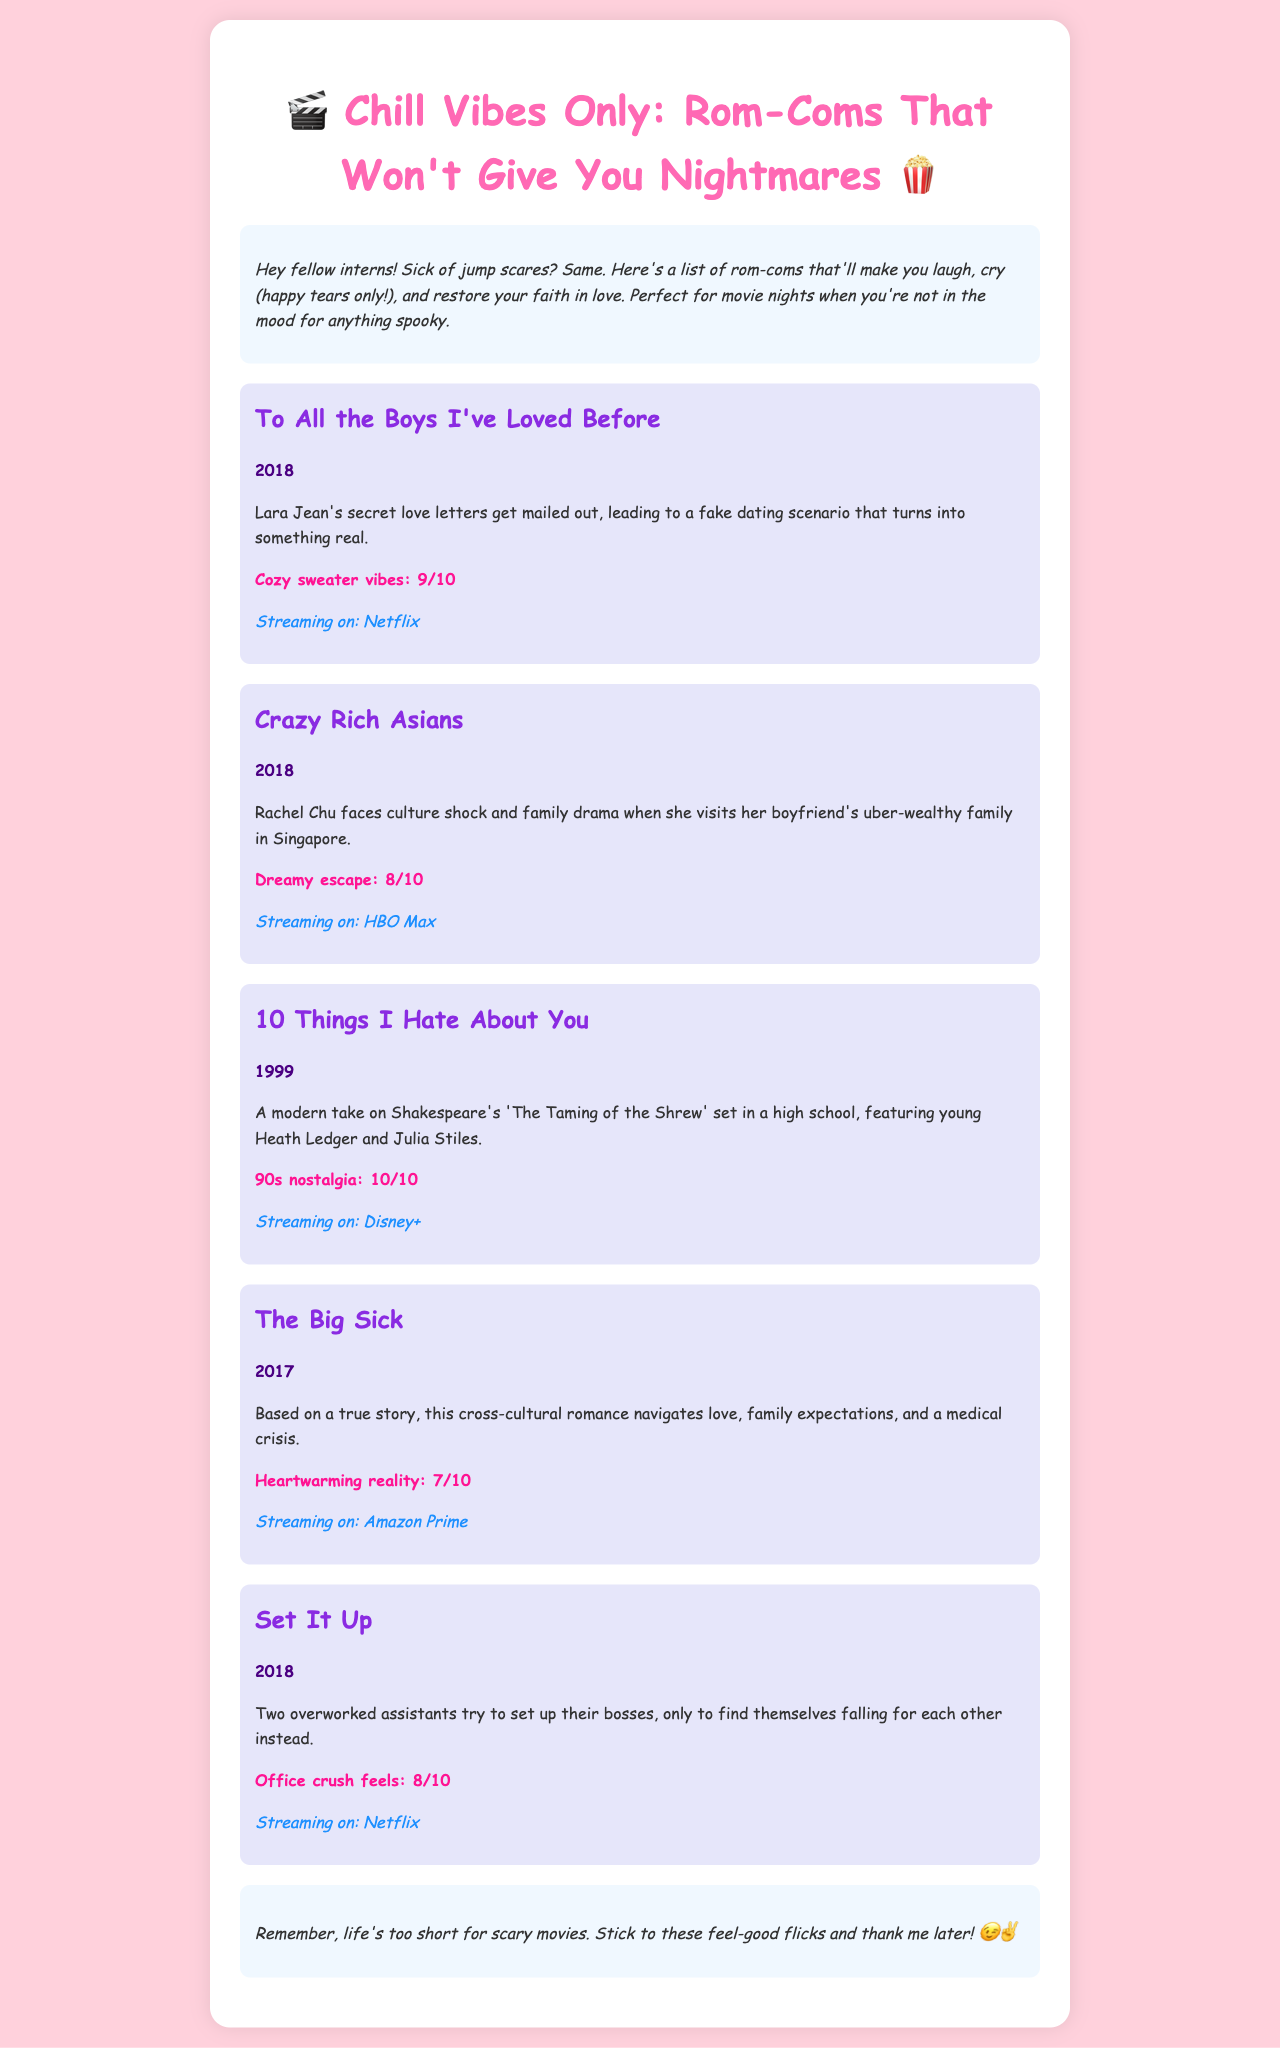what is the title of the first movie listed? The first movie listed in the document is the first entry in the curated collection.
Answer: To All the Boys I've Loved Before what year was "Crazy Rich Asians" released? The release year of "Crazy Rich Asians" is explicitly mentioned in the synopsis.
Answer: 2018 what is the mood rating for "10 Things I Hate About You"? The mood rating is provided for each movie, specifically for "10 Things I Hate About You".
Answer: 10/10 which streaming platform has "The Big Sick"? The streaming platform for "The Big Sick" is indicated in its details.
Answer: Amazon Prime what overarching theme do the movies share according to the introduction? The introduction states what common theme all the movies in the collection represent, focusing on the vibe they provide.
Answer: Feel-good romantic comedies which movie features a modern take on Shakespeare? The document explicitly states that one of the movies is a modern take on a Shakespeare play in its description.
Answer: 10 Things I Hate About You how many movies are listed in the catalog? The total number of movies can be counted from the number of individual movie entries present in the document.
Answer: 5 what kind of vibes does "Set It Up" evoke according to its mood rating? The mood rating gives a specific feeling associated with "Set It Up".
Answer: Office crush feels what audience is the document primarily targeted towards? The introduction hints at the target audience for this collection of films by referring to the document's style and purpose.
Answer: Fellow interns 